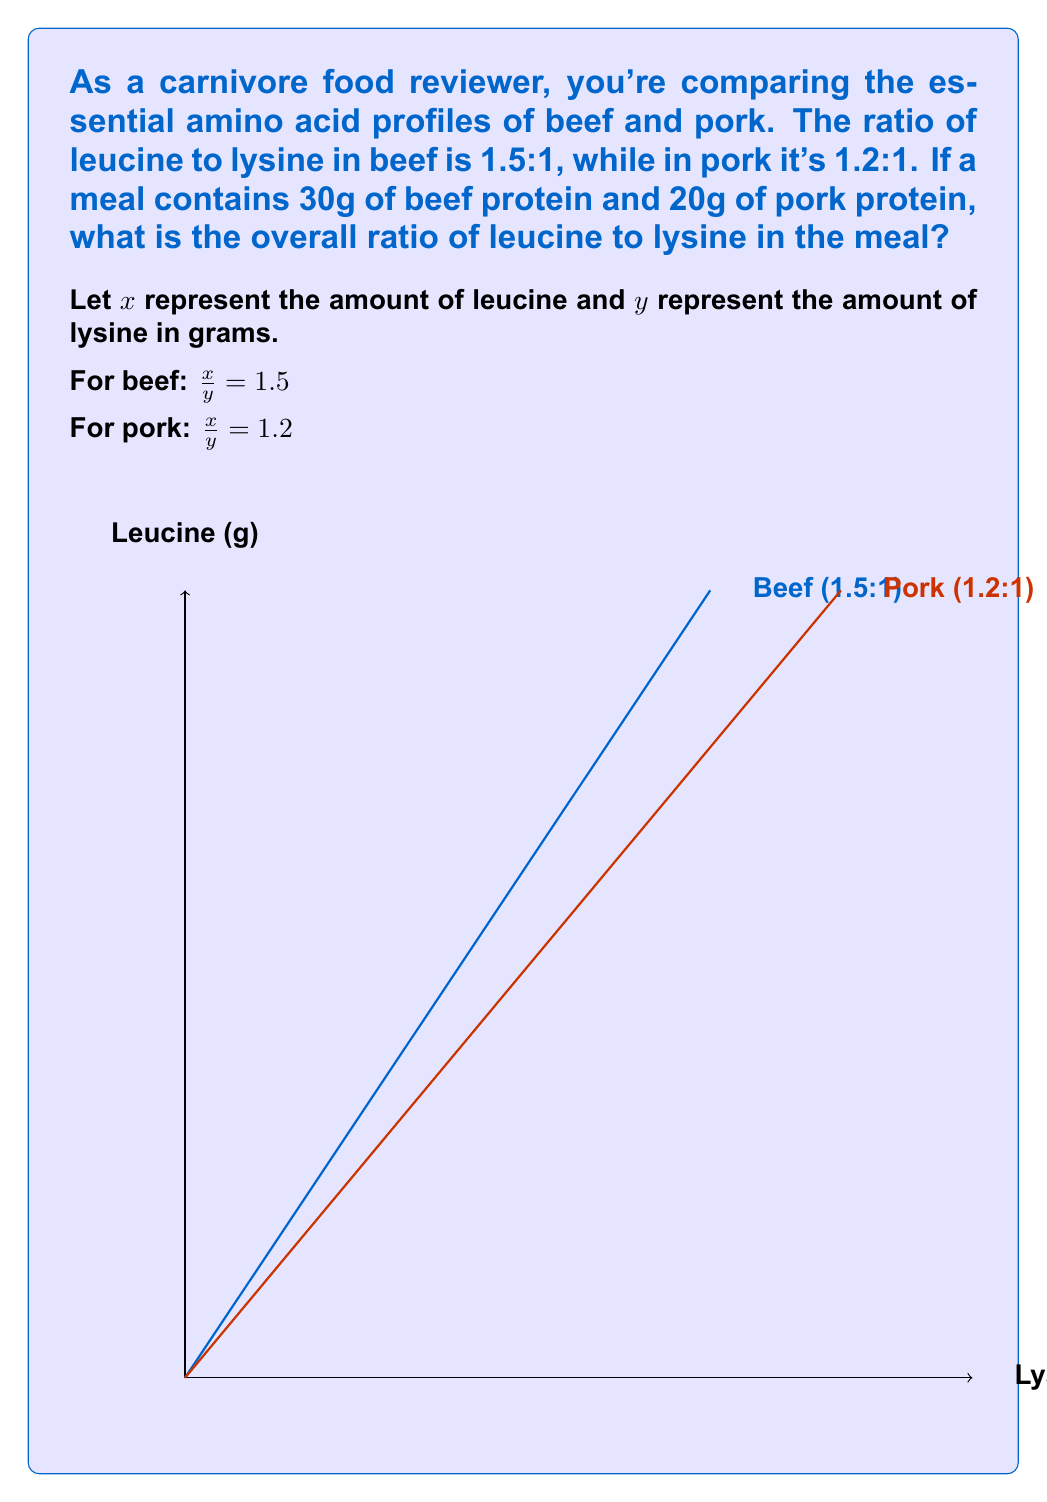Could you help me with this problem? Let's approach this step-by-step:

1) First, let's calculate the amounts of leucine and lysine in beef:
   For 30g of beef protein:
   $30 = x + y$
   $\frac{x}{y} = 1.5$
   
   Solving this system:
   $x = 18g$ of leucine
   $y = 12g$ of lysine

2) Now for pork:
   For 20g of pork protein:
   $20 = x + y$
   $\frac{x}{y} = 1.2$
   
   Solving this system:
   $x = 10.91g$ of leucine
   $y = 9.09g$ of lysine

3) Now, let's sum up the total leucine and lysine:
   Total leucine: $18 + 10.91 = 28.91g$
   Total lysine: $12 + 9.09 = 21.09g$

4) The ratio of leucine to lysine in the entire meal is:
   $\frac{\text{Total leucine}}{\text{Total lysine}} = \frac{28.91}{21.09} \approx 1.37$

Therefore, the overall ratio of leucine to lysine in the meal is approximately 1.37:1.
Answer: $1.37:1$ 